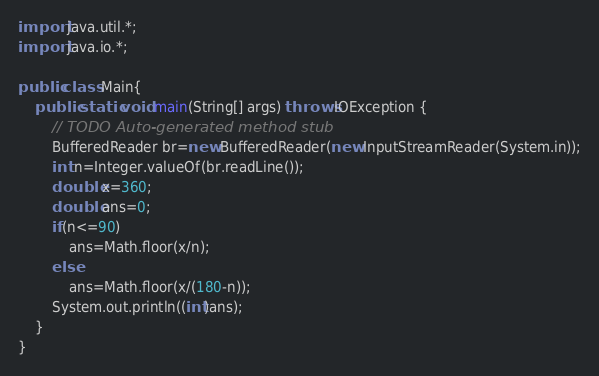Convert code to text. <code><loc_0><loc_0><loc_500><loc_500><_Java_>
import java.util.*;
import java.io.*;

public class Main{
	public static void main(String[] args) throws IOException {
		// TODO Auto-generated method stub
		BufferedReader br=new BufferedReader(new InputStreamReader(System.in));
		int n=Integer.valueOf(br.readLine());
		double x=360;
		double ans=0;
		if(n<=90)
			ans=Math.floor(x/n);
		else
			ans=Math.floor(x/(180-n));
		System.out.println((int)ans);
	}
}
</code> 